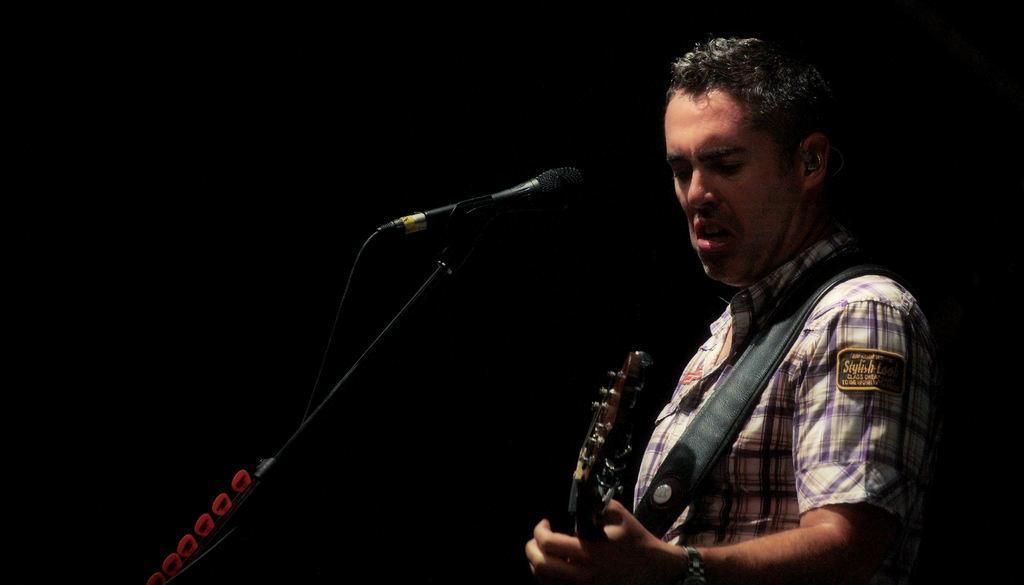In one or two sentences, can you explain what this image depicts? On the right side of this image there is a man holding a guitar in the hand. On the left side there is a mike stand. The background is in black color. 